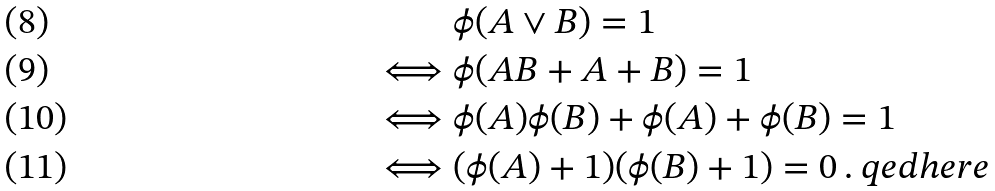Convert formula to latex. <formula><loc_0><loc_0><loc_500><loc_500>& \phi ( A \vee B ) = 1 \\ \iff & \phi ( A B + A + B ) = 1 \\ \iff & \phi ( A ) \phi ( B ) + \phi ( A ) + \phi ( B ) = 1 \\ \iff & ( \phi ( A ) + 1 ) ( \phi ( B ) + 1 ) = 0 \, . \ q e d h e r e</formula> 